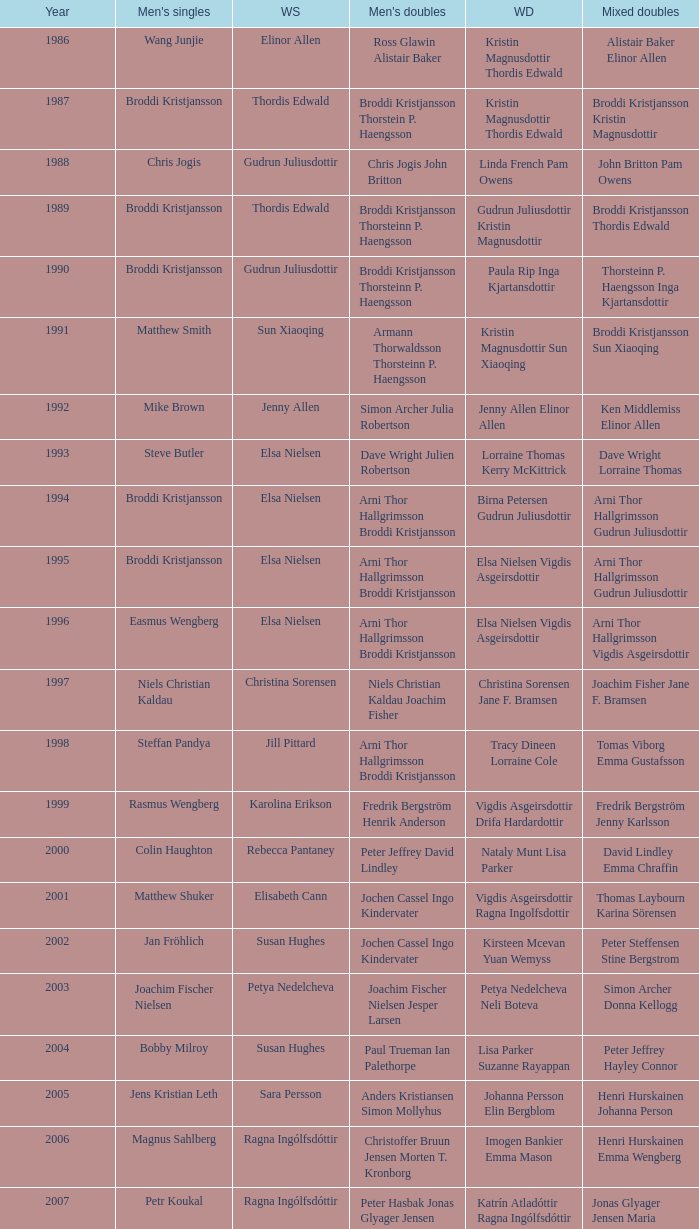Which mixed doubles contests featured niels christian kaldau playing in the men's singles division? Joachim Fisher Jane F. Bramsen. 